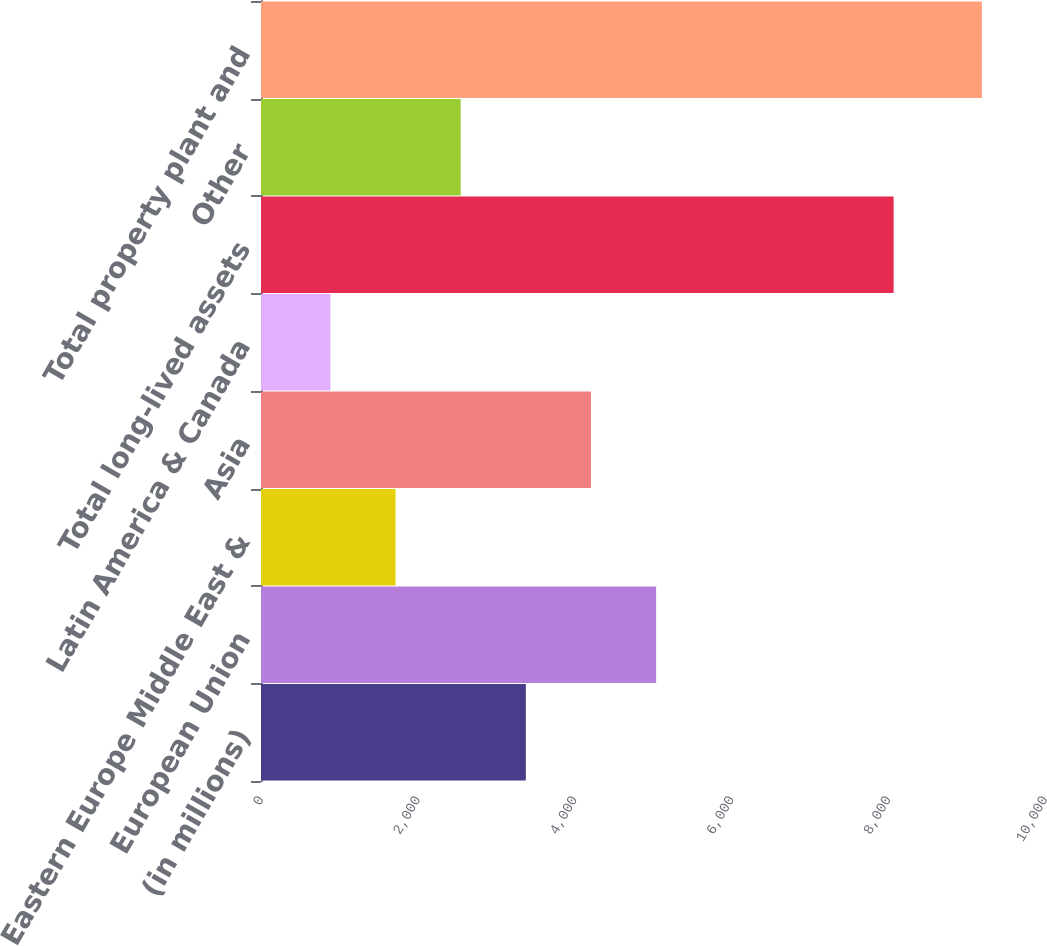Convert chart. <chart><loc_0><loc_0><loc_500><loc_500><bar_chart><fcel>(in millions)<fcel>European Union<fcel>Eastern Europe Middle East &<fcel>Asia<fcel>Latin America & Canada<fcel>Total long-lived assets<fcel>Other<fcel>Total property plant and<nl><fcel>3378<fcel>5040<fcel>1716<fcel>4209<fcel>885<fcel>8069<fcel>2547<fcel>9195<nl></chart> 